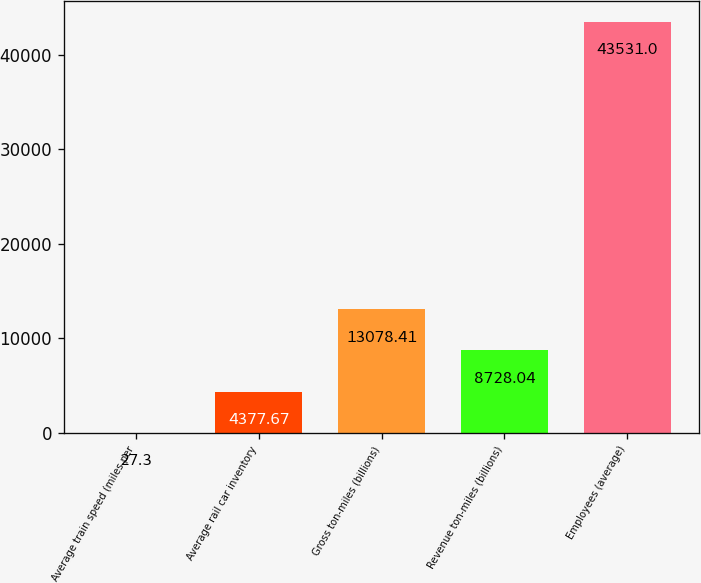<chart> <loc_0><loc_0><loc_500><loc_500><bar_chart><fcel>Average train speed (miles per<fcel>Average rail car inventory<fcel>Gross ton-miles (billions)<fcel>Revenue ton-miles (billions)<fcel>Employees (average)<nl><fcel>27.3<fcel>4377.67<fcel>13078.4<fcel>8728.04<fcel>43531<nl></chart> 